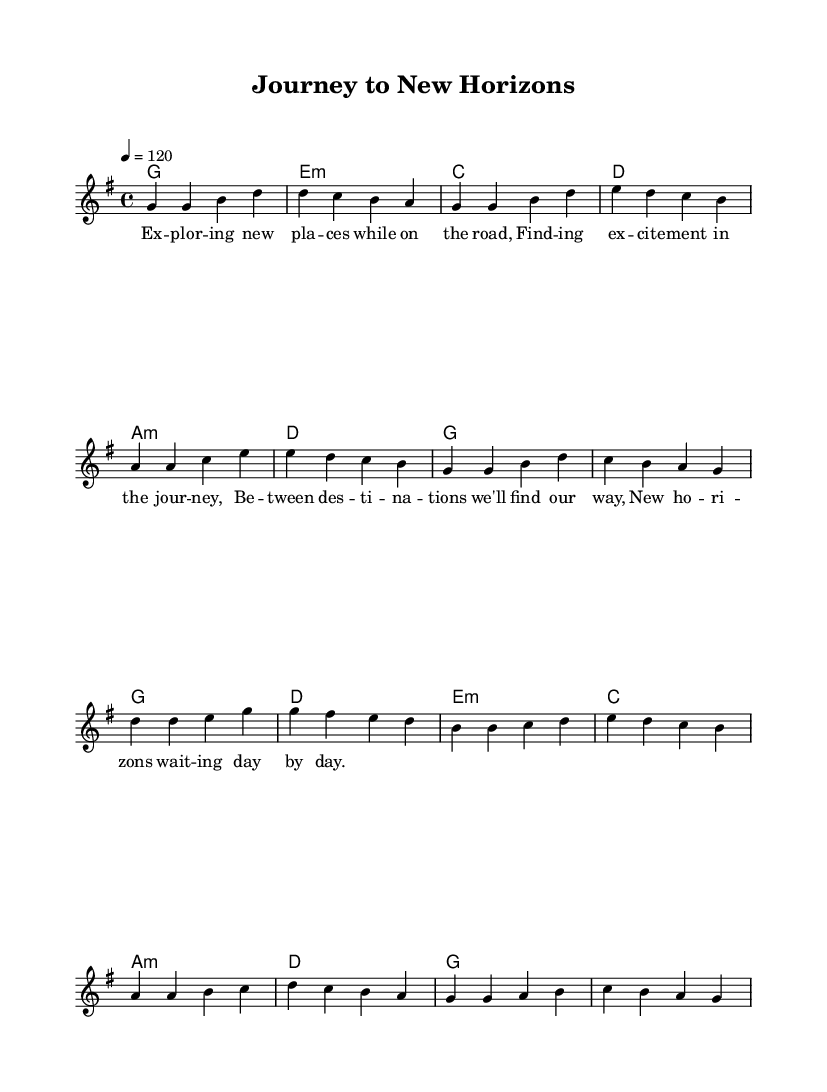What is the key signature of this music? The key signature is G major, which has one sharp (F#). This can be determined by looking at the key signature notation at the beginning of the sheet music.
Answer: G major What is the time signature of this piece? The time signature is 4/4, which is indicated at the beginning of the score. This means there are four beats in each measure, and the quarter note gets one beat.
Answer: 4/4 What is the tempo marking for the music? The tempo marking is 120 beats per minute. This is specified at the beginning of the score under the tempo indication.
Answer: 120 How many measures are in the verse section? The verse section consists of 8 measures. By counting the segments or phrases in the melody part labeled "Verse," there are 8 distinct measures that can be identified.
Answer: 8 measures What is the first note of the chorus? The first note of the chorus is D. This can be found by looking at the melody line where the "Chorus" section begins, and the first note is identified in the musical notation.
Answer: D What is the lyrical theme of the piece? The lyrical theme revolves around exploration and travel. This is evident from the lyrics provided, which discuss discovering new places and experiences during a journey.
Answer: Exploration and travel How many chords are used in the chorus? There are 4 chords used in the chorus section. By examining the chord changes denoted in the harmonies section corresponding to the "Chorus," four distinct chords can be identified.
Answer: 4 chords 